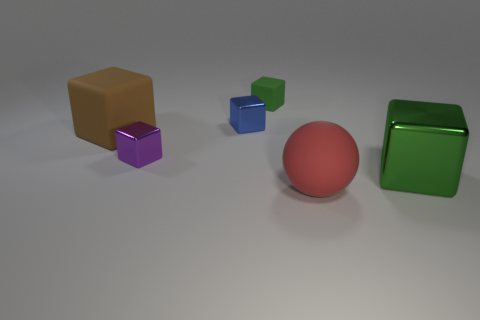Subtract 2 cubes. How many cubes are left? 3 Subtract all purple cubes. How many cubes are left? 4 Subtract all cyan cubes. Subtract all blue balls. How many cubes are left? 5 Add 1 green matte cubes. How many objects exist? 7 Subtract all spheres. How many objects are left? 5 Add 5 big red matte spheres. How many big red matte spheres exist? 6 Subtract 0 yellow balls. How many objects are left? 6 Subtract all small purple matte cubes. Subtract all tiny purple cubes. How many objects are left? 5 Add 3 matte blocks. How many matte blocks are left? 5 